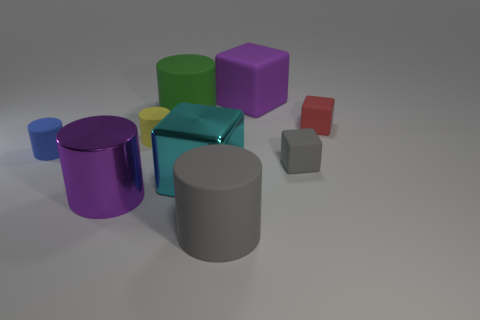Subtract all big purple metallic cylinders. How many cylinders are left? 4 Add 1 small red things. How many small red things are left? 2 Add 8 big yellow metallic balls. How many big yellow metallic balls exist? 8 Subtract all gray blocks. How many blocks are left? 3 Subtract 1 blue cylinders. How many objects are left? 8 Subtract all cylinders. How many objects are left? 4 Subtract 2 cubes. How many cubes are left? 2 Subtract all brown blocks. Subtract all yellow cylinders. How many blocks are left? 4 Subtract all cyan cylinders. How many purple cubes are left? 1 Subtract all small gray matte cubes. Subtract all brown cubes. How many objects are left? 8 